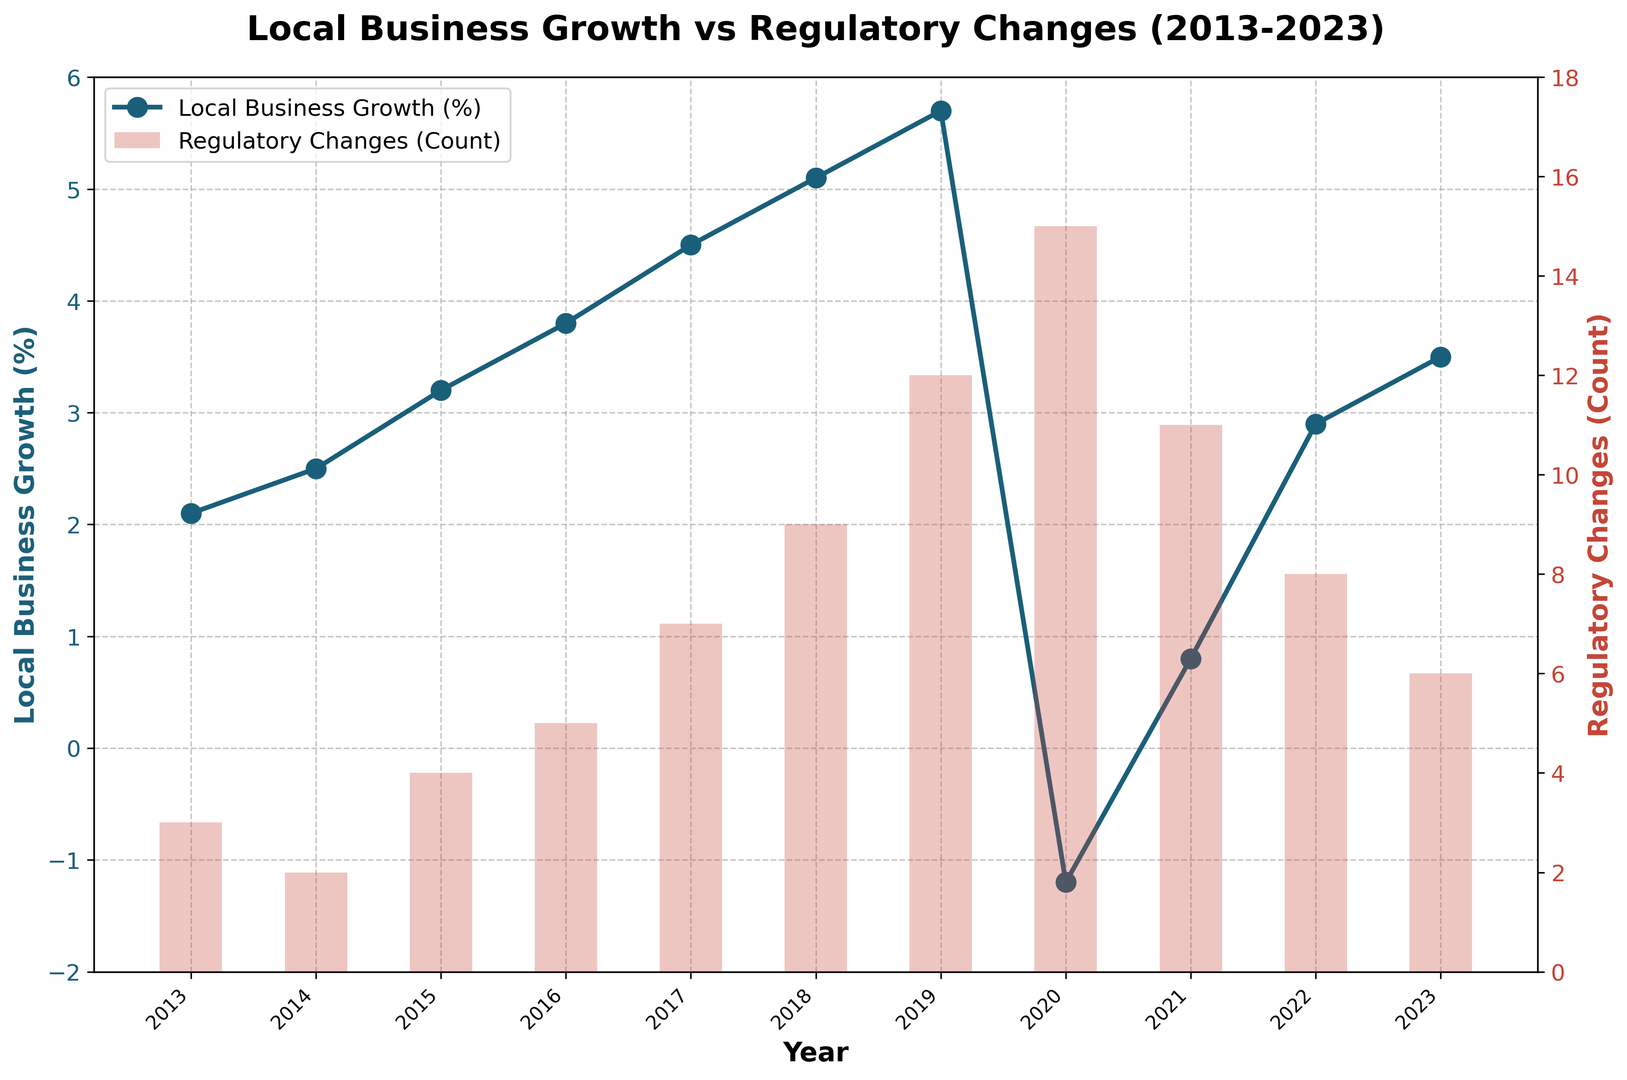What was the local business growth (%) in the year 2018? By inspecting the line in the plot labeled 'Local Business Growth (%)', we identify the value for the year 2018.
Answer: 5.1% What is the difference in local business growth between 2017 and 2019? From the plot, local business growth in 2017 is 4.5% and in 2019 is 5.7%. The difference can be calculated as 5.7% - 4.5%.
Answer: 1.2% How many regulatory changes occurred in the year 2020? The bar chart represents regulatory changes. By locating the year 2020 on the x-axis, we find the corresponding bar height.
Answer: 15 Which year observed a negative local business growth and what was the magnitude of the decline? By observing the line plot, it's evident that local business growth was negative in 2020, marked at -1.2%. Thus, the magnitude of the decline is 1.2%.
Answer: 2020, 1.2% Compare the local business growth (%) in 2021 to 2022. Which year was higher and by how much? By checking the line plot, the local business growth in 2021 is 0.8% and in 2022 is 2.9%. The increase can be calculated as 2.9% - 0.8%.
Answer: 2022, 2.1% What is the average number of regulatory changes over the period 2018 to 2020? From the bar chart, the regulatory changes are 9 in 2018, 12 in 2019, and 15 in 2020. The average is calculated as (9 + 12 + 15)/3.
Answer: 12 In which year did local business growth exceed 3% for the first time? By checking the line plot, local business growth first exceeds 3% in 2015 with a value of 3.2%.
Answer: 2015 How many times did the number of regulatory changes equal or exceed 10? From the bar chart, the regulatory changes meet or exceed 10 in 2019, 2020, and 2021. Counting these instances gives the answer.
Answer: 3 What is the trend of local business growth from 2013 to 2023? Observing the line plot, local business growth shows a general upward trend until 2019, a decline in 2020, followed by a recovery trend until 2023.
Answer: Upward trend with a dip in 2020 Did any year see both the local business growth decline and the number of regulatory changes exceed 10? The year 2020 saw a decline in local business growth (-1.2%) and the regulatory changes were 15, both conditions met.
Answer: 2020 